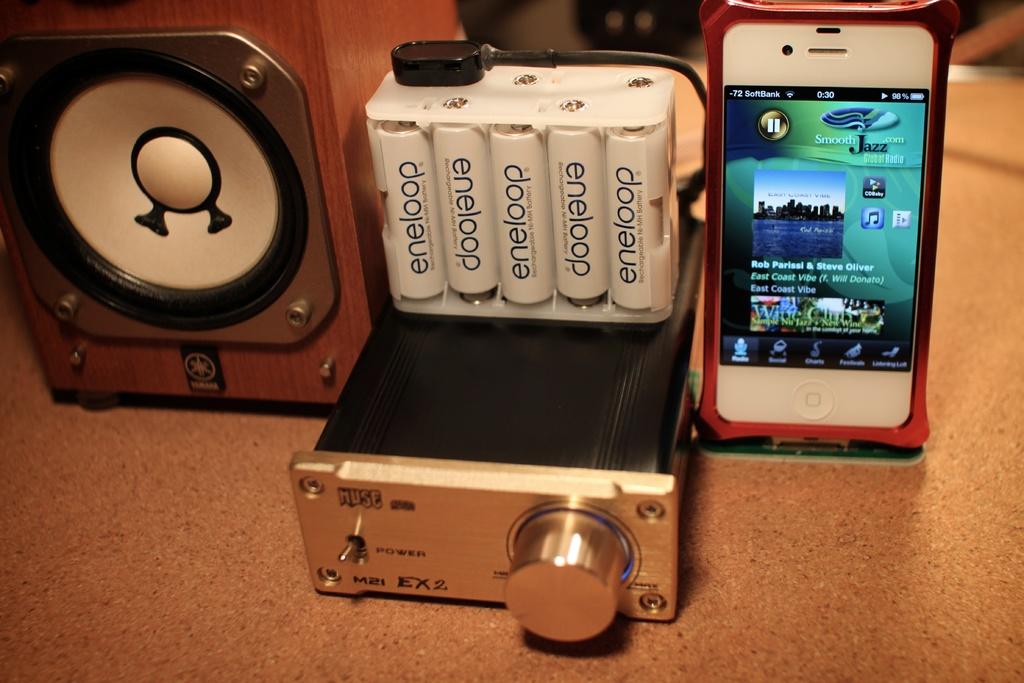What brand are the batteries?
Make the answer very short. Eneloop. 